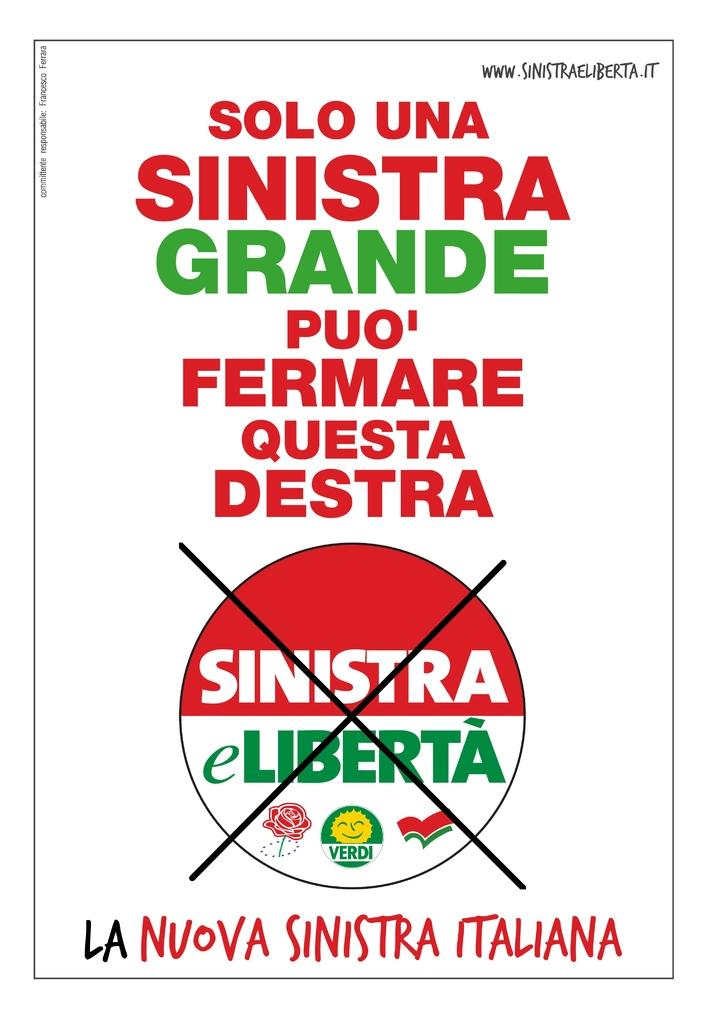<image>
Describe the image concisely. a poster that says sinistra on the front of it 